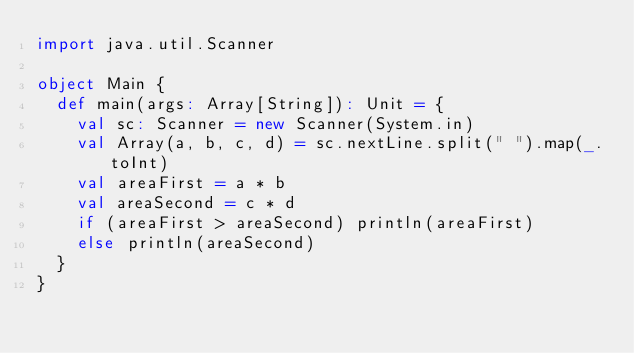Convert code to text. <code><loc_0><loc_0><loc_500><loc_500><_Scala_>import java.util.Scanner

object Main {
  def main(args: Array[String]): Unit = {
    val sc: Scanner = new Scanner(System.in)
    val Array(a, b, c, d) = sc.nextLine.split(" ").map(_.toInt)
    val areaFirst = a * b
    val areaSecond = c * d
    if (areaFirst > areaSecond) println(areaFirst)
    else println(areaSecond)
  }
}
</code> 